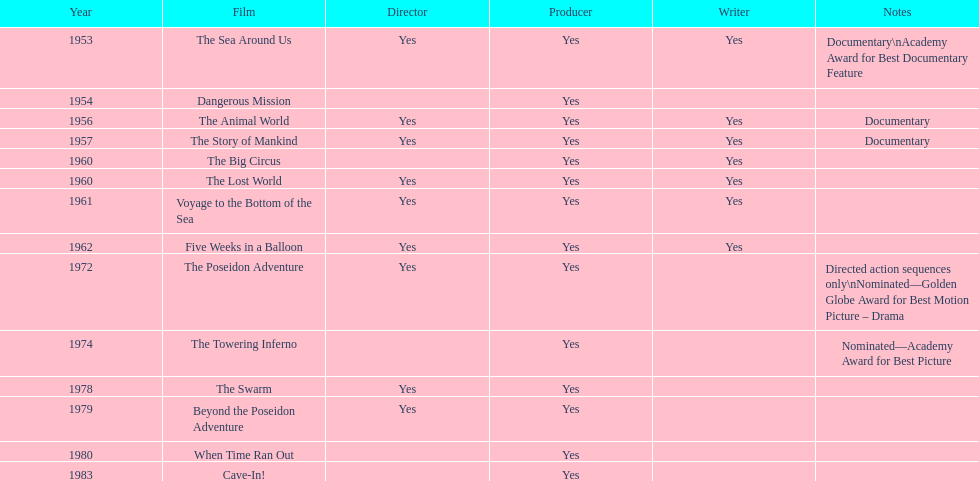What is the total number of movies directed, produced, and written by irwin allen? 6. Help me parse the entirety of this table. {'header': ['Year', 'Film', 'Director', 'Producer', 'Writer', 'Notes'], 'rows': [['1953', 'The Sea Around Us', 'Yes', 'Yes', 'Yes', 'Documentary\\nAcademy Award for Best Documentary Feature'], ['1954', 'Dangerous Mission', '', 'Yes', '', ''], ['1956', 'The Animal World', 'Yes', 'Yes', 'Yes', 'Documentary'], ['1957', 'The Story of Mankind', 'Yes', 'Yes', 'Yes', 'Documentary'], ['1960', 'The Big Circus', '', 'Yes', 'Yes', ''], ['1960', 'The Lost World', 'Yes', 'Yes', 'Yes', ''], ['1961', 'Voyage to the Bottom of the Sea', 'Yes', 'Yes', 'Yes', ''], ['1962', 'Five Weeks in a Balloon', 'Yes', 'Yes', 'Yes', ''], ['1972', 'The Poseidon Adventure', 'Yes', 'Yes', '', 'Directed action sequences only\\nNominated—Golden Globe Award for Best Motion Picture – Drama'], ['1974', 'The Towering Inferno', '', 'Yes', '', 'Nominated—Academy Award for Best Picture'], ['1978', 'The Swarm', 'Yes', 'Yes', '', ''], ['1979', 'Beyond the Poseidon Adventure', 'Yes', 'Yes', '', ''], ['1980', 'When Time Ran Out', '', 'Yes', '', ''], ['1983', 'Cave-In!', '', 'Yes', '', '']]} 